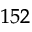<formula> <loc_0><loc_0><loc_500><loc_500>^ { 1 5 2 }</formula> 